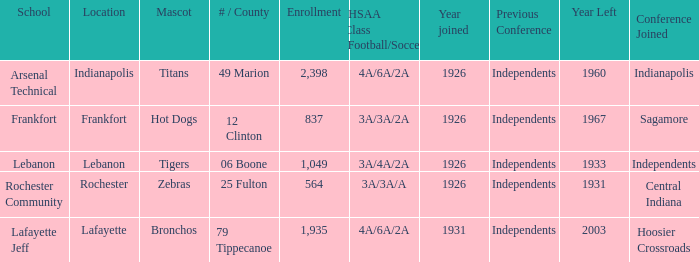What is the average enrollment that has hot dogs as the mascot, with a year joined later than 1926? None. 